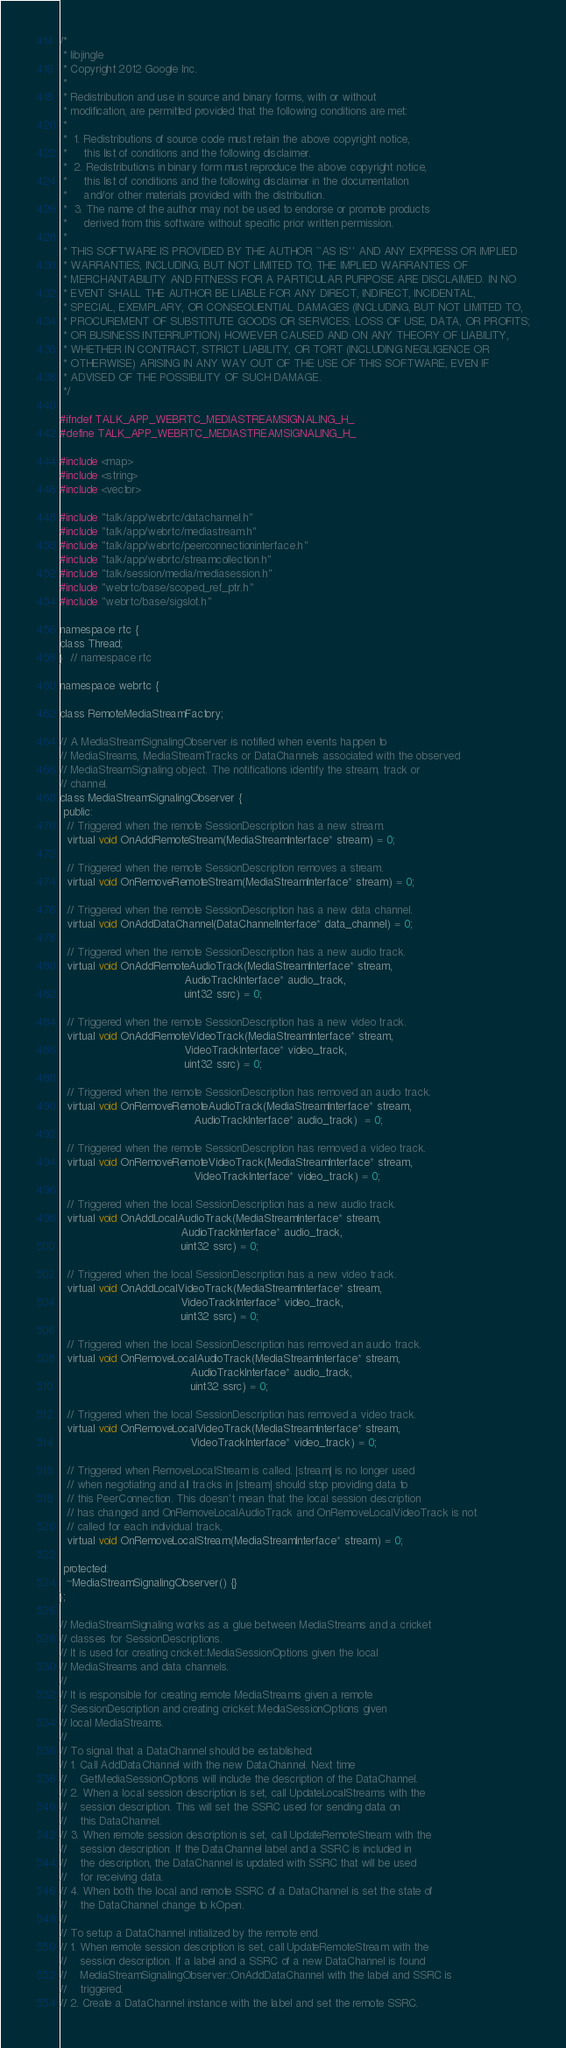<code> <loc_0><loc_0><loc_500><loc_500><_C_>/*
 * libjingle
 * Copyright 2012 Google Inc.
 *
 * Redistribution and use in source and binary forms, with or without
 * modification, are permitted provided that the following conditions are met:
 *
 *  1. Redistributions of source code must retain the above copyright notice,
 *     this list of conditions and the following disclaimer.
 *  2. Redistributions in binary form must reproduce the above copyright notice,
 *     this list of conditions and the following disclaimer in the documentation
 *     and/or other materials provided with the distribution.
 *  3. The name of the author may not be used to endorse or promote products
 *     derived from this software without specific prior written permission.
 *
 * THIS SOFTWARE IS PROVIDED BY THE AUTHOR ``AS IS'' AND ANY EXPRESS OR IMPLIED
 * WARRANTIES, INCLUDING, BUT NOT LIMITED TO, THE IMPLIED WARRANTIES OF
 * MERCHANTABILITY AND FITNESS FOR A PARTICULAR PURPOSE ARE DISCLAIMED. IN NO
 * EVENT SHALL THE AUTHOR BE LIABLE FOR ANY DIRECT, INDIRECT, INCIDENTAL,
 * SPECIAL, EXEMPLARY, OR CONSEQUENTIAL DAMAGES (INCLUDING, BUT NOT LIMITED TO,
 * PROCUREMENT OF SUBSTITUTE GOODS OR SERVICES; LOSS OF USE, DATA, OR PROFITS;
 * OR BUSINESS INTERRUPTION) HOWEVER CAUSED AND ON ANY THEORY OF LIABILITY,
 * WHETHER IN CONTRACT, STRICT LIABILITY, OR TORT (INCLUDING NEGLIGENCE OR
 * OTHERWISE) ARISING IN ANY WAY OUT OF THE USE OF THIS SOFTWARE, EVEN IF
 * ADVISED OF THE POSSIBILITY OF SUCH DAMAGE.
 */

#ifndef TALK_APP_WEBRTC_MEDIASTREAMSIGNALING_H_
#define TALK_APP_WEBRTC_MEDIASTREAMSIGNALING_H_

#include <map>
#include <string>
#include <vector>

#include "talk/app/webrtc/datachannel.h"
#include "talk/app/webrtc/mediastream.h"
#include "talk/app/webrtc/peerconnectioninterface.h"
#include "talk/app/webrtc/streamcollection.h"
#include "talk/session/media/mediasession.h"
#include "webrtc/base/scoped_ref_ptr.h"
#include "webrtc/base/sigslot.h"

namespace rtc {
class Thread;
}  // namespace rtc

namespace webrtc {

class RemoteMediaStreamFactory;

// A MediaStreamSignalingObserver is notified when events happen to
// MediaStreams, MediaStreamTracks or DataChannels associated with the observed
// MediaStreamSignaling object. The notifications identify the stream, track or
// channel.
class MediaStreamSignalingObserver {
 public:
  // Triggered when the remote SessionDescription has a new stream.
  virtual void OnAddRemoteStream(MediaStreamInterface* stream) = 0;

  // Triggered when the remote SessionDescription removes a stream.
  virtual void OnRemoveRemoteStream(MediaStreamInterface* stream) = 0;

  // Triggered when the remote SessionDescription has a new data channel.
  virtual void OnAddDataChannel(DataChannelInterface* data_channel) = 0;

  // Triggered when the remote SessionDescription has a new audio track.
  virtual void OnAddRemoteAudioTrack(MediaStreamInterface* stream,
                                     AudioTrackInterface* audio_track,
                                     uint32 ssrc) = 0;

  // Triggered when the remote SessionDescription has a new video track.
  virtual void OnAddRemoteVideoTrack(MediaStreamInterface* stream,
                                     VideoTrackInterface* video_track,
                                     uint32 ssrc) = 0;

  // Triggered when the remote SessionDescription has removed an audio track.
  virtual void OnRemoveRemoteAudioTrack(MediaStreamInterface* stream,
                                        AudioTrackInterface* audio_track)  = 0;

  // Triggered when the remote SessionDescription has removed a video track.
  virtual void OnRemoveRemoteVideoTrack(MediaStreamInterface* stream,
                                        VideoTrackInterface* video_track) = 0;

  // Triggered when the local SessionDescription has a new audio track.
  virtual void OnAddLocalAudioTrack(MediaStreamInterface* stream,
                                    AudioTrackInterface* audio_track,
                                    uint32 ssrc) = 0;

  // Triggered when the local SessionDescription has a new video track.
  virtual void OnAddLocalVideoTrack(MediaStreamInterface* stream,
                                    VideoTrackInterface* video_track,
                                    uint32 ssrc) = 0;

  // Triggered when the local SessionDescription has removed an audio track.
  virtual void OnRemoveLocalAudioTrack(MediaStreamInterface* stream,
                                       AudioTrackInterface* audio_track,
                                       uint32 ssrc) = 0;

  // Triggered when the local SessionDescription has removed a video track.
  virtual void OnRemoveLocalVideoTrack(MediaStreamInterface* stream,
                                       VideoTrackInterface* video_track) = 0;

  // Triggered when RemoveLocalStream is called. |stream| is no longer used
  // when negotiating and all tracks in |stream| should stop providing data to
  // this PeerConnection. This doesn't mean that the local session description
  // has changed and OnRemoveLocalAudioTrack and OnRemoveLocalVideoTrack is not
  // called for each individual track.
  virtual void OnRemoveLocalStream(MediaStreamInterface* stream) = 0;

 protected:
  ~MediaStreamSignalingObserver() {}
};

// MediaStreamSignaling works as a glue between MediaStreams and a cricket
// classes for SessionDescriptions.
// It is used for creating cricket::MediaSessionOptions given the local
// MediaStreams and data channels.
//
// It is responsible for creating remote MediaStreams given a remote
// SessionDescription and creating cricket::MediaSessionOptions given
// local MediaStreams.
//
// To signal that a DataChannel should be established:
// 1. Call AddDataChannel with the new DataChannel. Next time
//    GetMediaSessionOptions will include the description of the DataChannel.
// 2. When a local session description is set, call UpdateLocalStreams with the
//    session description. This will set the SSRC used for sending data on
//    this DataChannel.
// 3. When remote session description is set, call UpdateRemoteStream with the
//    session description. If the DataChannel label and a SSRC is included in
//    the description, the DataChannel is updated with SSRC that will be used
//    for receiving data.
// 4. When both the local and remote SSRC of a DataChannel is set the state of
//    the DataChannel change to kOpen.
//
// To setup a DataChannel initialized by the remote end.
// 1. When remote session description is set, call UpdateRemoteStream with the
//    session description. If a label and a SSRC of a new DataChannel is found
//    MediaStreamSignalingObserver::OnAddDataChannel with the label and SSRC is
//    triggered.
// 2. Create a DataChannel instance with the label and set the remote SSRC.</code> 